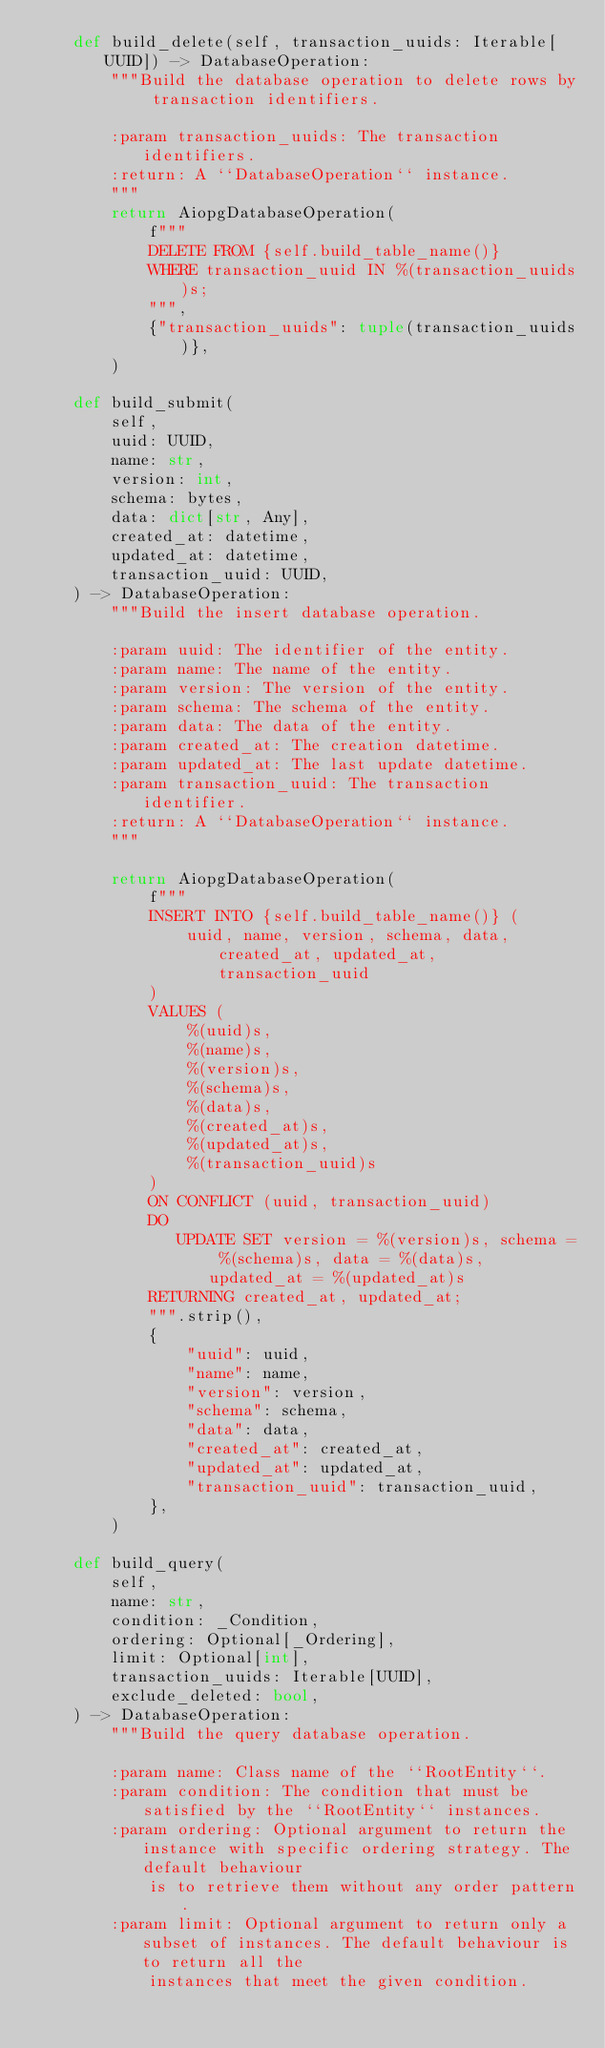Convert code to text. <code><loc_0><loc_0><loc_500><loc_500><_Python_>    def build_delete(self, transaction_uuids: Iterable[UUID]) -> DatabaseOperation:
        """Build the database operation to delete rows by transaction identifiers.

        :param transaction_uuids: The transaction identifiers.
        :return: A ``DatabaseOperation`` instance.
        """
        return AiopgDatabaseOperation(
            f"""
            DELETE FROM {self.build_table_name()}
            WHERE transaction_uuid IN %(transaction_uuids)s;
            """,
            {"transaction_uuids": tuple(transaction_uuids)},
        )

    def build_submit(
        self,
        uuid: UUID,
        name: str,
        version: int,
        schema: bytes,
        data: dict[str, Any],
        created_at: datetime,
        updated_at: datetime,
        transaction_uuid: UUID,
    ) -> DatabaseOperation:
        """Build the insert database operation.

        :param uuid: The identifier of the entity.
        :param name: The name of the entity.
        :param version: The version of the entity.
        :param schema: The schema of the entity.
        :param data: The data of the entity.
        :param created_at: The creation datetime.
        :param updated_at: The last update datetime.
        :param transaction_uuid: The transaction identifier.
        :return: A ``DatabaseOperation`` instance.
        """

        return AiopgDatabaseOperation(
            f"""
            INSERT INTO {self.build_table_name()} (
                uuid, name, version, schema, data, created_at, updated_at, transaction_uuid
            )
            VALUES (
                %(uuid)s,
                %(name)s,
                %(version)s,
                %(schema)s,
                %(data)s,
                %(created_at)s,
                %(updated_at)s,
                %(transaction_uuid)s
            )
            ON CONFLICT (uuid, transaction_uuid)
            DO
               UPDATE SET version = %(version)s, schema = %(schema)s, data = %(data)s, updated_at = %(updated_at)s
            RETURNING created_at, updated_at;
            """.strip(),
            {
                "uuid": uuid,
                "name": name,
                "version": version,
                "schema": schema,
                "data": data,
                "created_at": created_at,
                "updated_at": updated_at,
                "transaction_uuid": transaction_uuid,
            },
        )

    def build_query(
        self,
        name: str,
        condition: _Condition,
        ordering: Optional[_Ordering],
        limit: Optional[int],
        transaction_uuids: Iterable[UUID],
        exclude_deleted: bool,
    ) -> DatabaseOperation:
        """Build the query database operation.

        :param name: Class name of the ``RootEntity``.
        :param condition: The condition that must be satisfied by the ``RootEntity`` instances.
        :param ordering: Optional argument to return the instance with specific ordering strategy. The default behaviour
            is to retrieve them without any order pattern.
        :param limit: Optional argument to return only a subset of instances. The default behaviour is to return all the
            instances that meet the given condition.</code> 